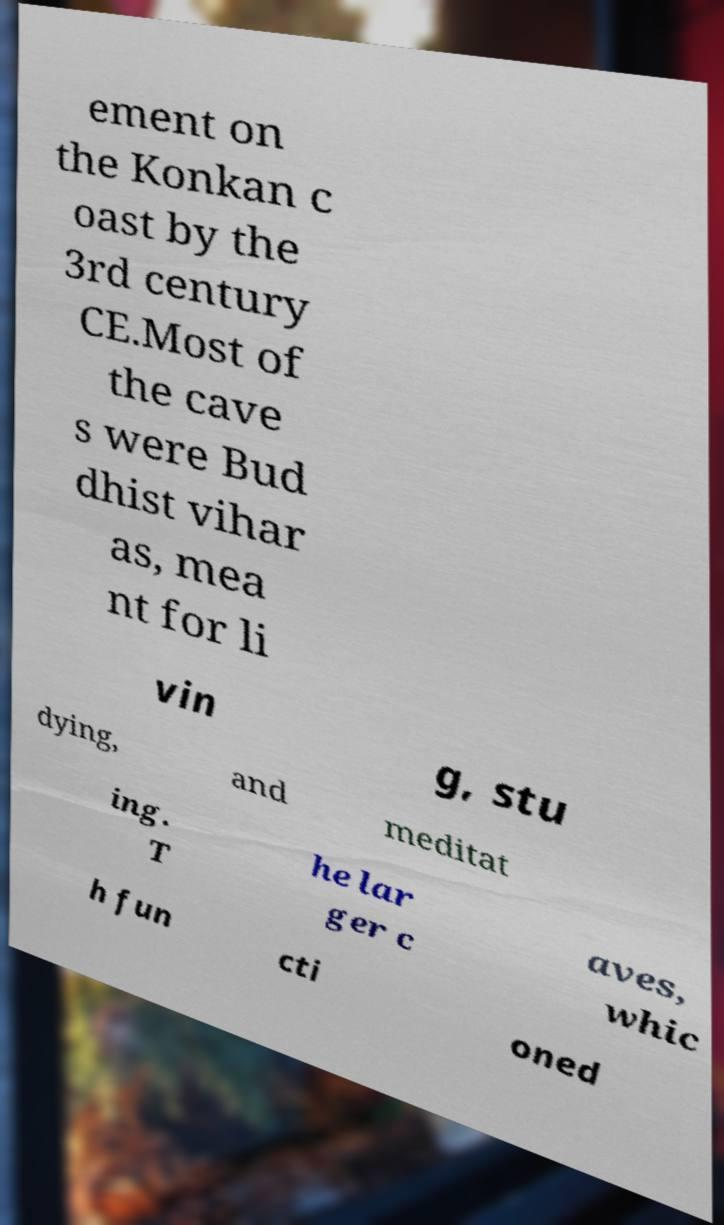Can you accurately transcribe the text from the provided image for me? ement on the Konkan c oast by the 3rd century CE.Most of the cave s were Bud dhist vihar as, mea nt for li vin g, stu dying, and meditat ing. T he lar ger c aves, whic h fun cti oned 